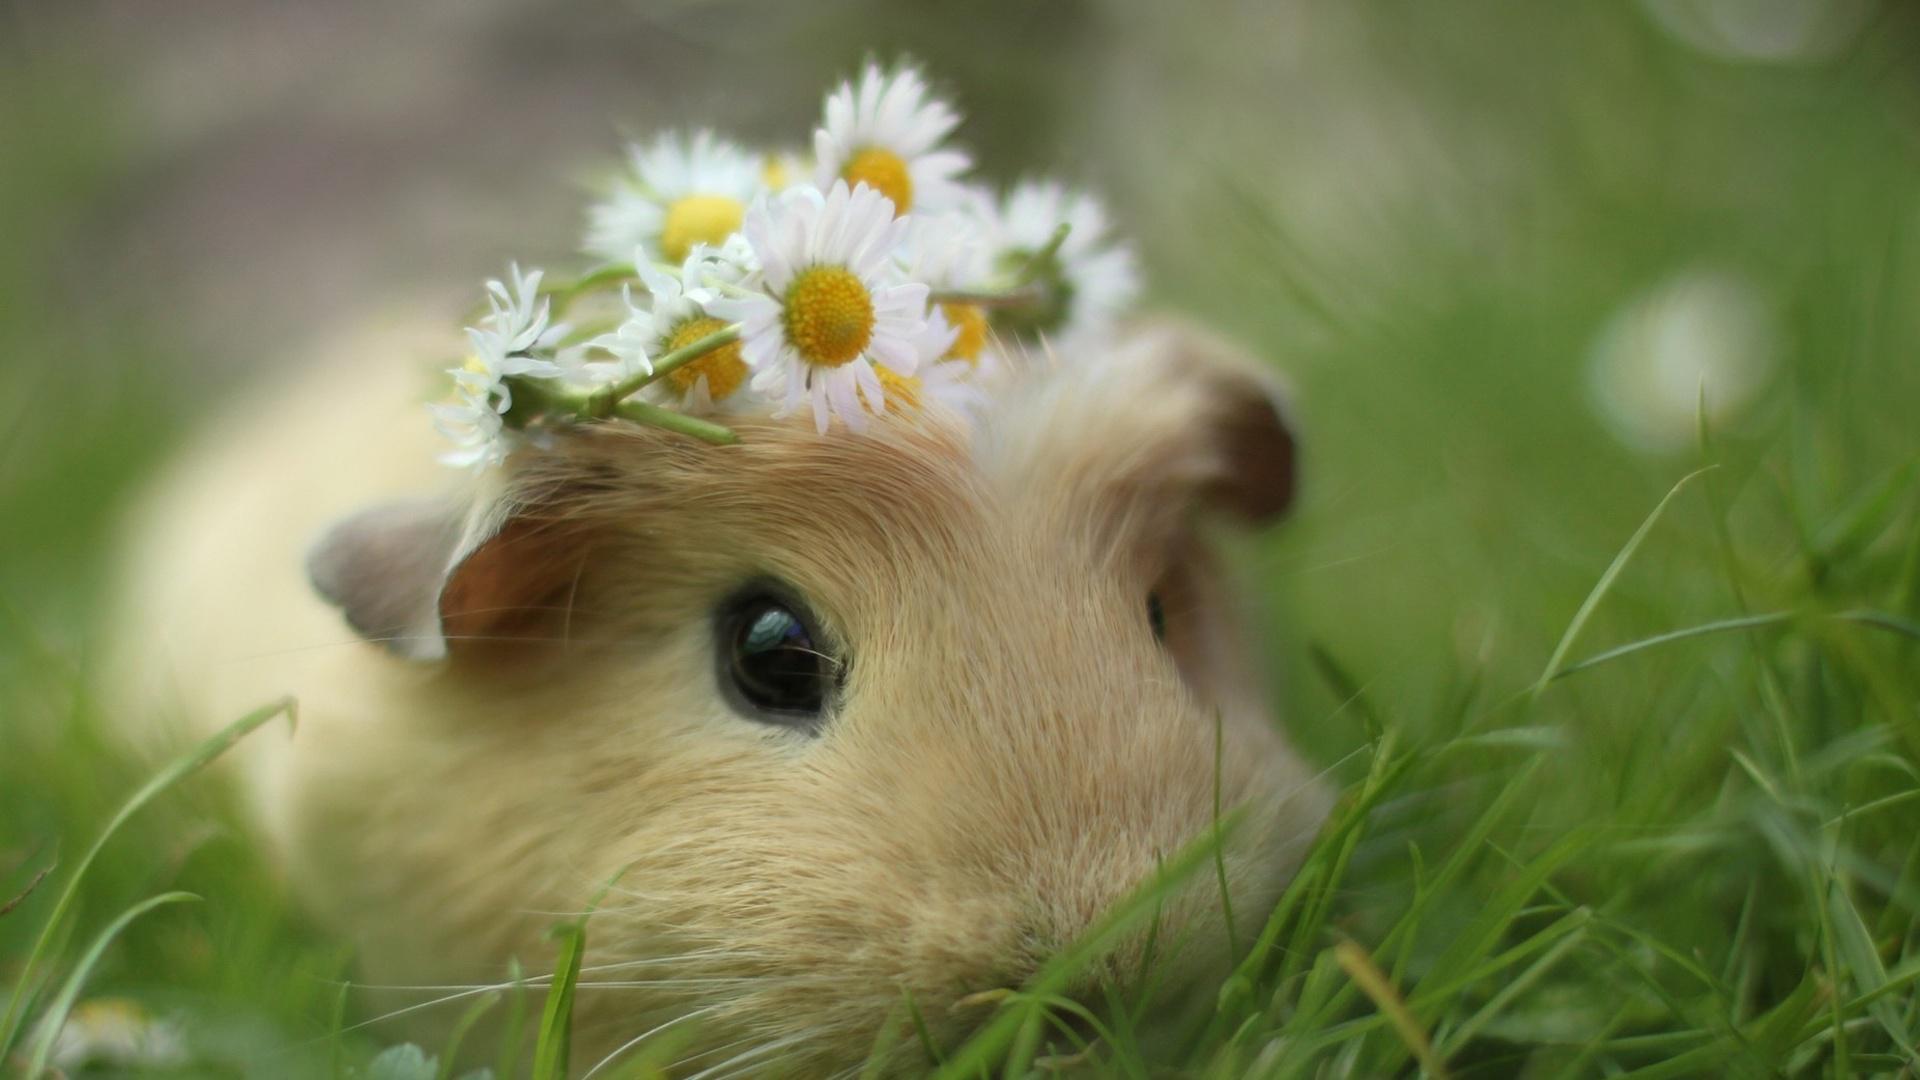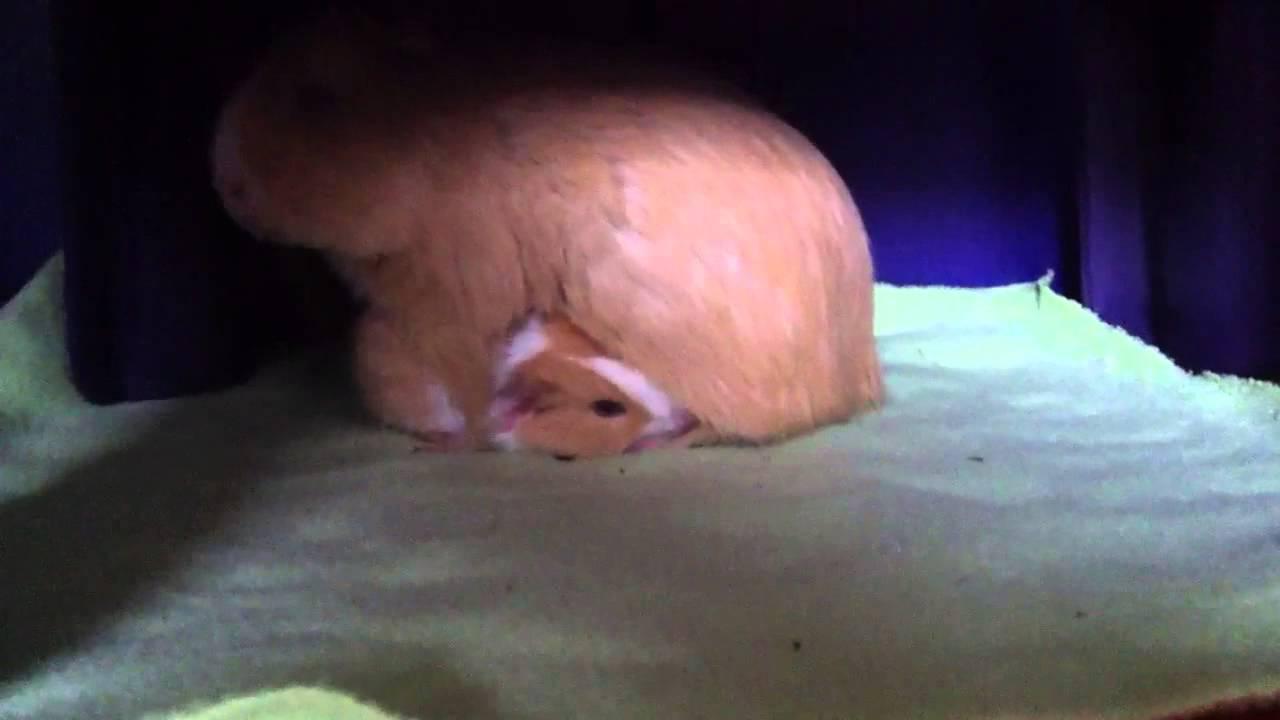The first image is the image on the left, the second image is the image on the right. Analyze the images presented: Is the assertion "Left image shows a pair of hands holding a tri-colored hamster." valid? Answer yes or no. No. The first image is the image on the left, the second image is the image on the right. For the images shown, is this caption "In one of the images there is a pair of cupped hands holding a baby guinea pig." true? Answer yes or no. No. 